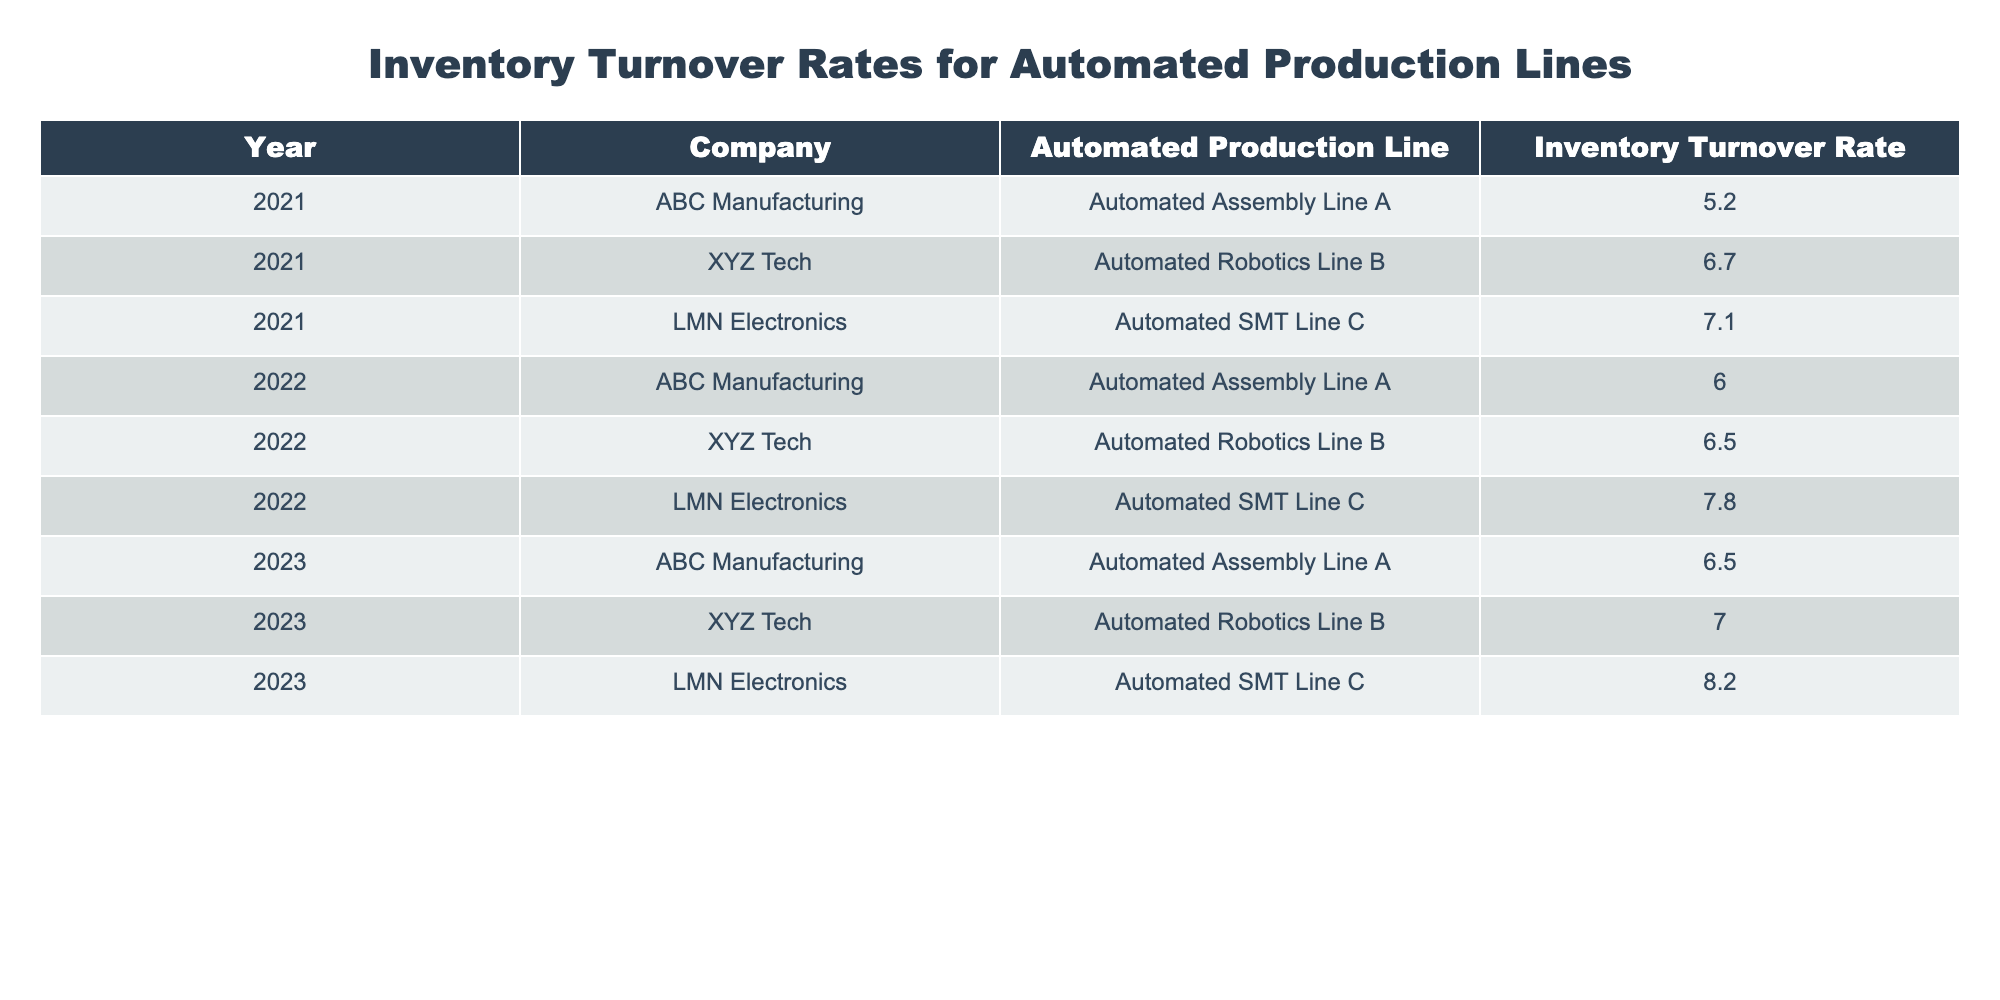What was the inventory turnover rate for LMN Electronics in 2022? In the table, we look for the row that corresponds to LMN Electronics in the year 2022. Referring to the specific row, we can see that it has an inventory turnover rate of 7.8.
Answer: 7.8 Which company had the highest inventory turnover rate in 2023? Checking the 2023 row for each company, we find that LMN Electronics has the highest turnover rate of 8.2, compared to ABC Manufacturing's 6.5 and XYZ Tech's 7.0.
Answer: LMN Electronics What is the average inventory turnover rate for ABC Manufacturing over the three years? First, we identify ABC Manufacturing's rates in each year: 5.2 (2021), 6.0 (2022), and 6.5 (2023). Next, we sum these values: 5.2 + 6.0 + 6.5 = 17.7. Finally, we divide by the number of years (3) to find the average: 17.7 / 3 = 5.9.
Answer: 5.9 Did XYZ Tech's inventory turnover rate improve from 2021 to 2023? By examining the rates for XYZ Tech, we see that it was 6.7 in 2021 and improved to 7.0 in 2023. Since 7.0 is greater than 6.7, the turnover rate did indeed improve over this period.
Answer: Yes What was the total inventory turnover rate for all companies in 2022? We need to find the turnover rates for each company in 2022: ABC Manufacturing had 6.0, XYZ Tech had 6.5, and LMN Electronics had 7.8. Summing these rates gives us 6.0 + 6.5 + 7.8 = 20.3.
Answer: 20.3 Did any automated production lines have the same inventory turnover rate in any year? By inspecting the table, we see that all rates for different companies and years are unique; hence, no automated production lines share the same inventory turnover rate in any year.
Answer: No Which line had the lowest turnover in 2021, and what was its rate? We look through the inventory turnover rates of all companies in 2021. The lowest rate is 5.2, which belongs to ABC Manufacturing with its Automated Assembly Line A.
Answer: ABC Manufacturing, 5.2 What is the percentage increase in turnover rate for LMN Electronics from 2021 to 2023? First, we note LMN Electronics’ rates: 7.1 in 2021 and 8.2 in 2023. The increase is 8.2 - 7.1 = 1.1. To find the percentage increase, we use the formula: (Increase / Original Rate) * 100 = (1.1 / 7.1) * 100 which equals approximately 15.5%.
Answer: 15.5% 